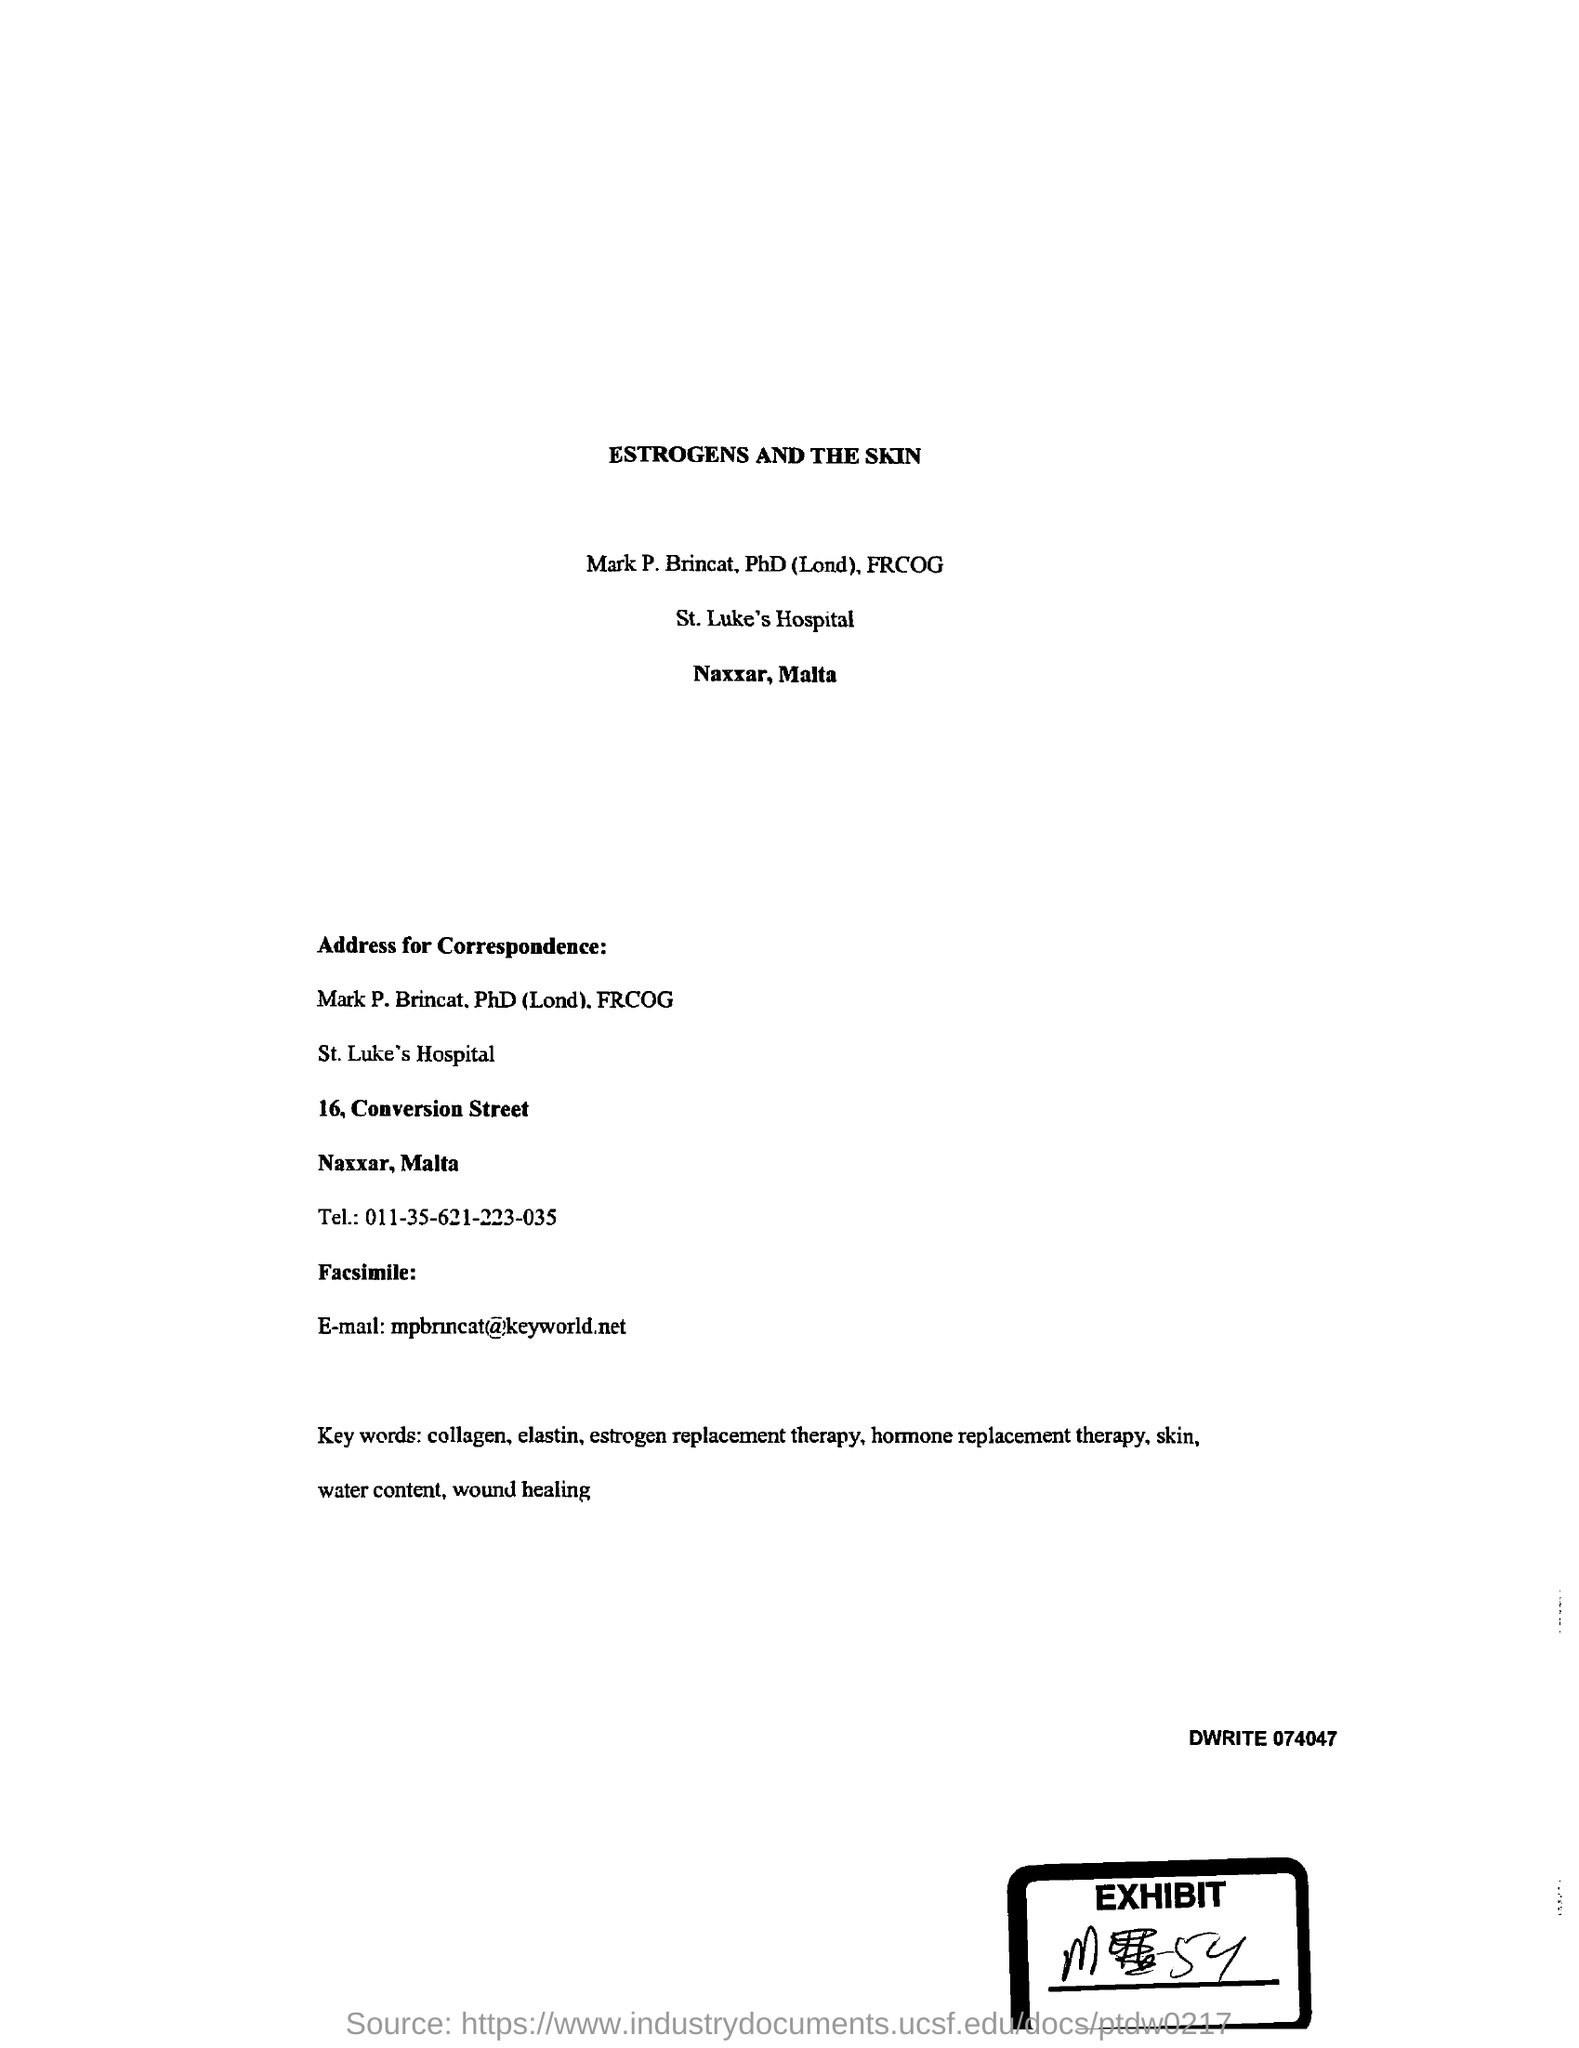Point out several critical features in this image. The name of the hospital is St. Luke's Hospital. The document is titled "Estrogens and the Skin. The telephone number is 011-35-621223-035. The email address is [mpbrincat@keyworld.net](mailto:mpbrincat@keyworld.net). 